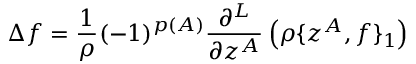<formula> <loc_0><loc_0><loc_500><loc_500>\Delta f = \frac { 1 } { \rho } ( - 1 ) ^ { p ( A ) } \frac { \partial ^ { L } } { \partial z ^ { A } } \left ( \rho \{ z ^ { A } , f \} _ { 1 } \right )</formula> 